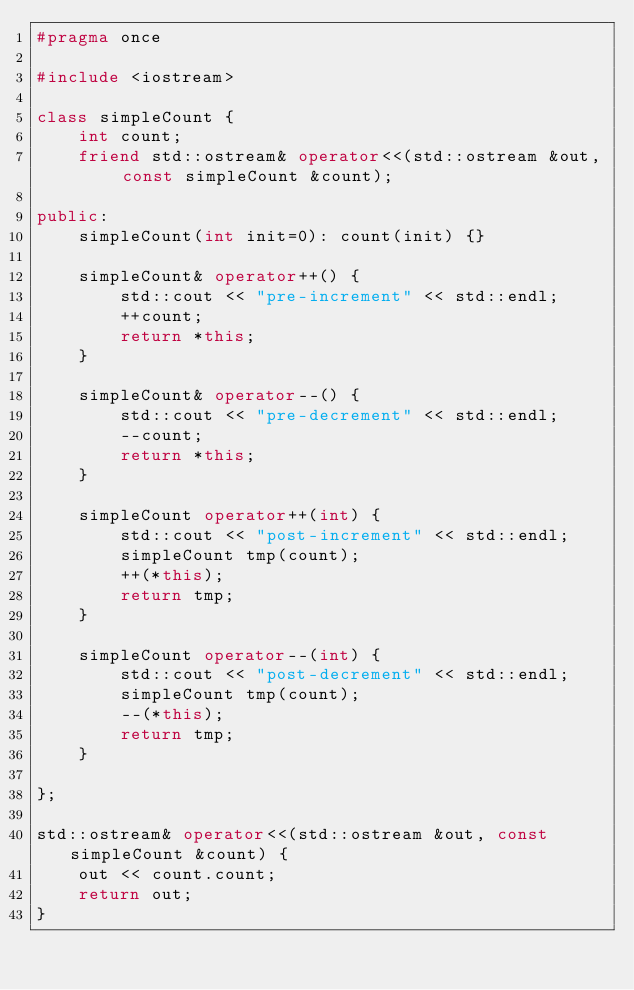<code> <loc_0><loc_0><loc_500><loc_500><_C++_>#pragma once

#include <iostream>

class simpleCount {
    int count;
    friend std::ostream& operator<<(std::ostream &out, const simpleCount &count);

public:
    simpleCount(int init=0): count(init) {}

    simpleCount& operator++() {
        std::cout << "pre-increment" << std::endl;
        ++count;
        return *this;
    }

    simpleCount& operator--() {
        std::cout << "pre-decrement" << std::endl;
        --count;
        return *this;
    }

    simpleCount operator++(int) {
        std::cout << "post-increment" << std::endl;
        simpleCount tmp(count);
        ++(*this);
        return tmp;
    }

    simpleCount operator--(int) {
        std::cout << "post-decrement" << std::endl;
        simpleCount tmp(count);
        --(*this);
        return tmp;
    }

};

std::ostream& operator<<(std::ostream &out, const simpleCount &count) {
    out << count.count;
    return out;
}
</code> 